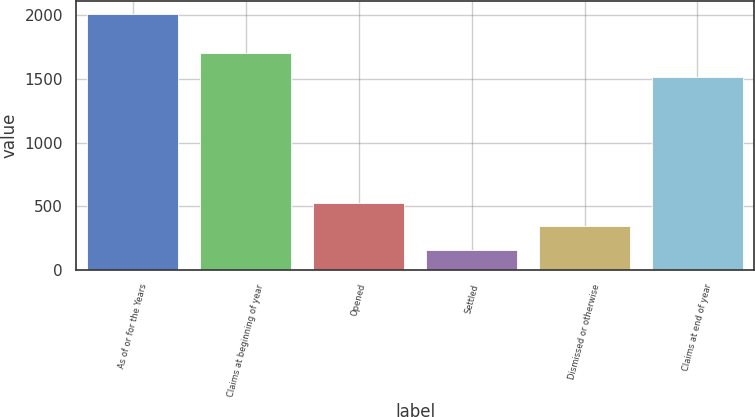Convert chart. <chart><loc_0><loc_0><loc_500><loc_500><bar_chart><fcel>As of or for the Years<fcel>Claims at beginning of year<fcel>Opened<fcel>Settled<fcel>Dismissed or otherwise<fcel>Claims at end of year<nl><fcel>2013<fcel>1702.9<fcel>525.8<fcel>154<fcel>339.9<fcel>1517<nl></chart> 